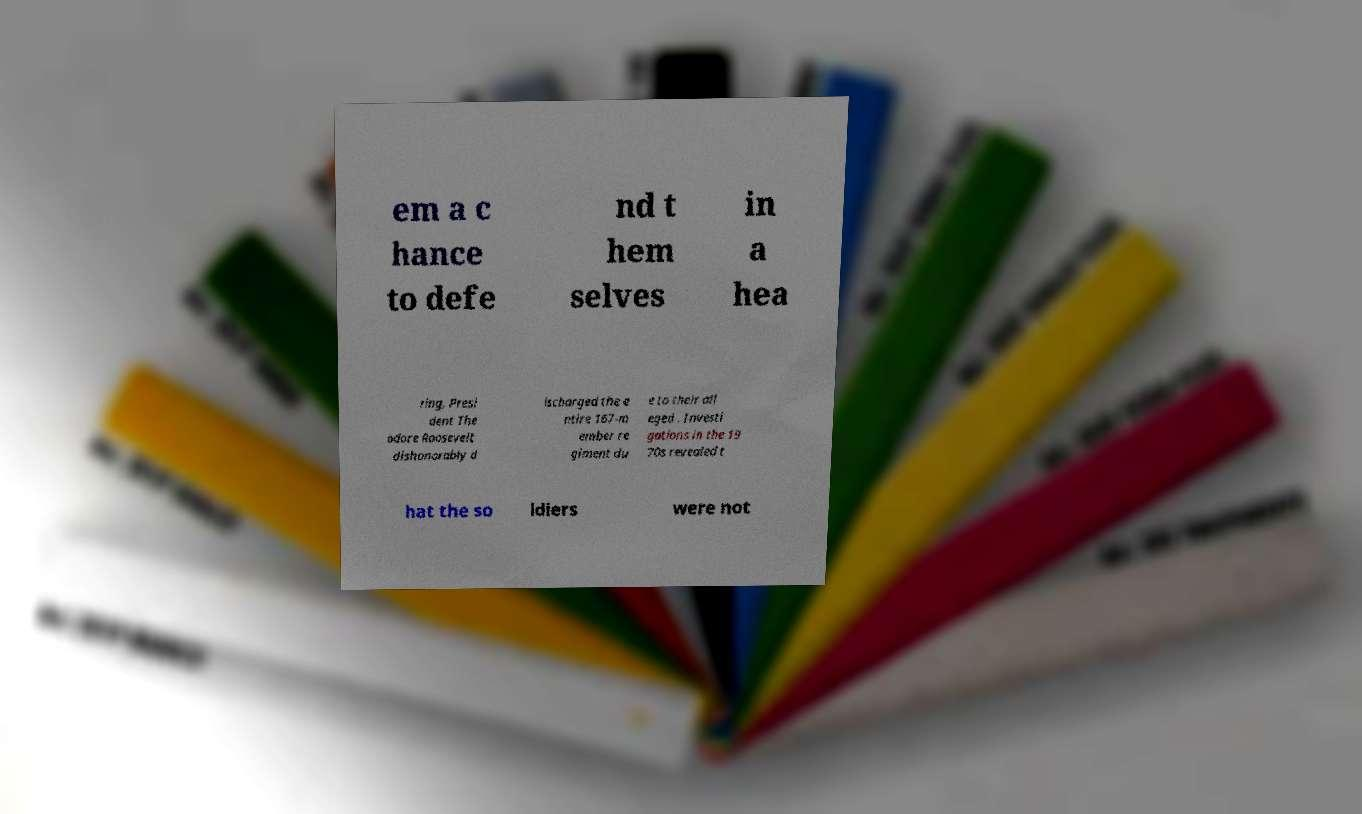Please identify and transcribe the text found in this image. em a c hance to defe nd t hem selves in a hea ring, Presi dent The odore Roosevelt dishonorably d ischarged the e ntire 167-m ember re giment du e to their all eged . Investi gations in the 19 70s revealed t hat the so ldiers were not 